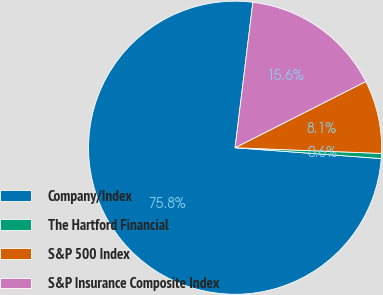<chart> <loc_0><loc_0><loc_500><loc_500><pie_chart><fcel>Company/Index<fcel>The Hartford Financial<fcel>S&P 500 Index<fcel>S&P Insurance Composite Index<nl><fcel>75.76%<fcel>0.56%<fcel>8.08%<fcel>15.6%<nl></chart> 